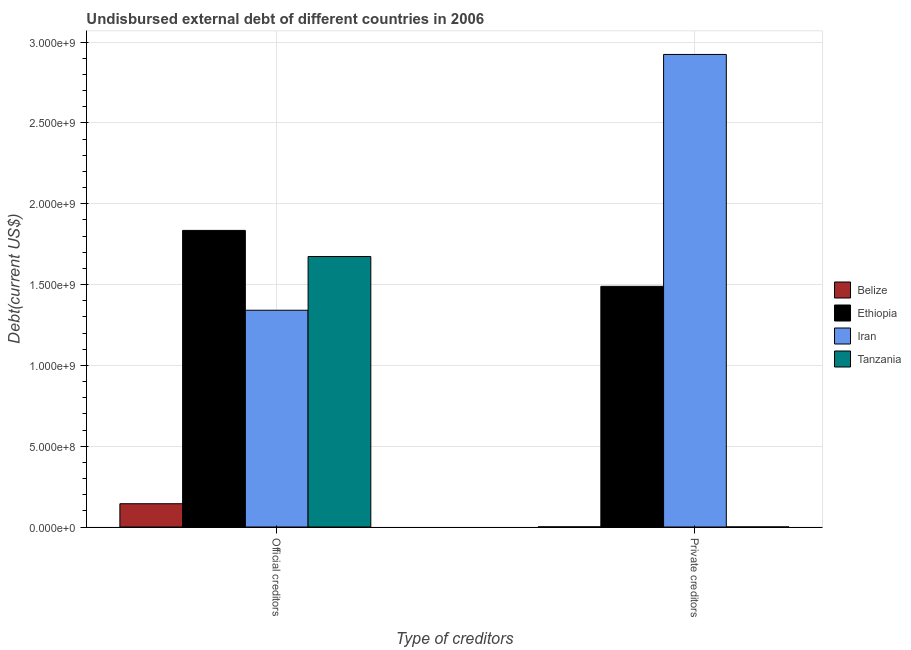How many groups of bars are there?
Your answer should be very brief. 2. Are the number of bars per tick equal to the number of legend labels?
Your response must be concise. Yes. What is the label of the 2nd group of bars from the left?
Your response must be concise. Private creditors. What is the undisbursed external debt of private creditors in Iran?
Your answer should be very brief. 2.92e+09. Across all countries, what is the maximum undisbursed external debt of private creditors?
Your answer should be very brief. 2.92e+09. Across all countries, what is the minimum undisbursed external debt of official creditors?
Your answer should be very brief. 1.44e+08. In which country was the undisbursed external debt of private creditors maximum?
Offer a terse response. Iran. In which country was the undisbursed external debt of private creditors minimum?
Provide a short and direct response. Tanzania. What is the total undisbursed external debt of official creditors in the graph?
Your answer should be compact. 4.99e+09. What is the difference between the undisbursed external debt of official creditors in Ethiopia and that in Belize?
Offer a very short reply. 1.69e+09. What is the difference between the undisbursed external debt of official creditors in Ethiopia and the undisbursed external debt of private creditors in Tanzania?
Give a very brief answer. 1.83e+09. What is the average undisbursed external debt of official creditors per country?
Make the answer very short. 1.25e+09. What is the difference between the undisbursed external debt of private creditors and undisbursed external debt of official creditors in Ethiopia?
Your response must be concise. -3.46e+08. What is the ratio of the undisbursed external debt of private creditors in Tanzania to that in Belize?
Give a very brief answer. 0.46. Is the undisbursed external debt of private creditors in Tanzania less than that in Iran?
Keep it short and to the point. Yes. What does the 1st bar from the left in Official creditors represents?
Your answer should be very brief. Belize. What does the 1st bar from the right in Private creditors represents?
Your answer should be compact. Tanzania. How many bars are there?
Give a very brief answer. 8. How many countries are there in the graph?
Give a very brief answer. 4. Are the values on the major ticks of Y-axis written in scientific E-notation?
Provide a short and direct response. Yes. Does the graph contain any zero values?
Offer a terse response. No. What is the title of the graph?
Your answer should be very brief. Undisbursed external debt of different countries in 2006. Does "Gabon" appear as one of the legend labels in the graph?
Your answer should be very brief. No. What is the label or title of the X-axis?
Ensure brevity in your answer.  Type of creditors. What is the label or title of the Y-axis?
Offer a very short reply. Debt(current US$). What is the Debt(current US$) in Belize in Official creditors?
Keep it short and to the point. 1.44e+08. What is the Debt(current US$) in Ethiopia in Official creditors?
Ensure brevity in your answer.  1.83e+09. What is the Debt(current US$) of Iran in Official creditors?
Your answer should be compact. 1.34e+09. What is the Debt(current US$) in Tanzania in Official creditors?
Your response must be concise. 1.67e+09. What is the Debt(current US$) in Belize in Private creditors?
Provide a succinct answer. 8.87e+05. What is the Debt(current US$) of Ethiopia in Private creditors?
Offer a terse response. 1.49e+09. What is the Debt(current US$) of Iran in Private creditors?
Provide a succinct answer. 2.92e+09. What is the Debt(current US$) in Tanzania in Private creditors?
Provide a short and direct response. 4.06e+05. Across all Type of creditors, what is the maximum Debt(current US$) in Belize?
Offer a terse response. 1.44e+08. Across all Type of creditors, what is the maximum Debt(current US$) of Ethiopia?
Your answer should be very brief. 1.83e+09. Across all Type of creditors, what is the maximum Debt(current US$) in Iran?
Provide a short and direct response. 2.92e+09. Across all Type of creditors, what is the maximum Debt(current US$) of Tanzania?
Offer a very short reply. 1.67e+09. Across all Type of creditors, what is the minimum Debt(current US$) of Belize?
Your answer should be compact. 8.87e+05. Across all Type of creditors, what is the minimum Debt(current US$) in Ethiopia?
Ensure brevity in your answer.  1.49e+09. Across all Type of creditors, what is the minimum Debt(current US$) in Iran?
Your response must be concise. 1.34e+09. Across all Type of creditors, what is the minimum Debt(current US$) in Tanzania?
Your response must be concise. 4.06e+05. What is the total Debt(current US$) in Belize in the graph?
Ensure brevity in your answer.  1.45e+08. What is the total Debt(current US$) of Ethiopia in the graph?
Your answer should be very brief. 3.32e+09. What is the total Debt(current US$) of Iran in the graph?
Your answer should be very brief. 4.26e+09. What is the total Debt(current US$) in Tanzania in the graph?
Provide a short and direct response. 1.67e+09. What is the difference between the Debt(current US$) of Belize in Official creditors and that in Private creditors?
Your answer should be compact. 1.43e+08. What is the difference between the Debt(current US$) in Ethiopia in Official creditors and that in Private creditors?
Your answer should be very brief. 3.46e+08. What is the difference between the Debt(current US$) in Iran in Official creditors and that in Private creditors?
Give a very brief answer. -1.58e+09. What is the difference between the Debt(current US$) of Tanzania in Official creditors and that in Private creditors?
Your answer should be very brief. 1.67e+09. What is the difference between the Debt(current US$) of Belize in Official creditors and the Debt(current US$) of Ethiopia in Private creditors?
Your answer should be very brief. -1.34e+09. What is the difference between the Debt(current US$) of Belize in Official creditors and the Debt(current US$) of Iran in Private creditors?
Your answer should be compact. -2.78e+09. What is the difference between the Debt(current US$) in Belize in Official creditors and the Debt(current US$) in Tanzania in Private creditors?
Provide a short and direct response. 1.44e+08. What is the difference between the Debt(current US$) in Ethiopia in Official creditors and the Debt(current US$) in Iran in Private creditors?
Provide a short and direct response. -1.09e+09. What is the difference between the Debt(current US$) of Ethiopia in Official creditors and the Debt(current US$) of Tanzania in Private creditors?
Your response must be concise. 1.83e+09. What is the difference between the Debt(current US$) of Iran in Official creditors and the Debt(current US$) of Tanzania in Private creditors?
Ensure brevity in your answer.  1.34e+09. What is the average Debt(current US$) in Belize per Type of creditors?
Your answer should be compact. 7.24e+07. What is the average Debt(current US$) of Ethiopia per Type of creditors?
Keep it short and to the point. 1.66e+09. What is the average Debt(current US$) of Iran per Type of creditors?
Offer a very short reply. 2.13e+09. What is the average Debt(current US$) of Tanzania per Type of creditors?
Provide a succinct answer. 8.37e+08. What is the difference between the Debt(current US$) in Belize and Debt(current US$) in Ethiopia in Official creditors?
Ensure brevity in your answer.  -1.69e+09. What is the difference between the Debt(current US$) in Belize and Debt(current US$) in Iran in Official creditors?
Keep it short and to the point. -1.20e+09. What is the difference between the Debt(current US$) in Belize and Debt(current US$) in Tanzania in Official creditors?
Offer a very short reply. -1.53e+09. What is the difference between the Debt(current US$) in Ethiopia and Debt(current US$) in Iran in Official creditors?
Your response must be concise. 4.94e+08. What is the difference between the Debt(current US$) of Ethiopia and Debt(current US$) of Tanzania in Official creditors?
Offer a very short reply. 1.62e+08. What is the difference between the Debt(current US$) of Iran and Debt(current US$) of Tanzania in Official creditors?
Your answer should be compact. -3.32e+08. What is the difference between the Debt(current US$) of Belize and Debt(current US$) of Ethiopia in Private creditors?
Offer a terse response. -1.49e+09. What is the difference between the Debt(current US$) in Belize and Debt(current US$) in Iran in Private creditors?
Make the answer very short. -2.92e+09. What is the difference between the Debt(current US$) of Belize and Debt(current US$) of Tanzania in Private creditors?
Keep it short and to the point. 4.81e+05. What is the difference between the Debt(current US$) of Ethiopia and Debt(current US$) of Iran in Private creditors?
Offer a terse response. -1.43e+09. What is the difference between the Debt(current US$) in Ethiopia and Debt(current US$) in Tanzania in Private creditors?
Provide a succinct answer. 1.49e+09. What is the difference between the Debt(current US$) of Iran and Debt(current US$) of Tanzania in Private creditors?
Offer a terse response. 2.92e+09. What is the ratio of the Debt(current US$) in Belize in Official creditors to that in Private creditors?
Your answer should be compact. 162.34. What is the ratio of the Debt(current US$) in Ethiopia in Official creditors to that in Private creditors?
Your response must be concise. 1.23. What is the ratio of the Debt(current US$) of Iran in Official creditors to that in Private creditors?
Provide a short and direct response. 0.46. What is the ratio of the Debt(current US$) in Tanzania in Official creditors to that in Private creditors?
Provide a succinct answer. 4121.39. What is the difference between the highest and the second highest Debt(current US$) of Belize?
Your response must be concise. 1.43e+08. What is the difference between the highest and the second highest Debt(current US$) of Ethiopia?
Give a very brief answer. 3.46e+08. What is the difference between the highest and the second highest Debt(current US$) in Iran?
Your answer should be very brief. 1.58e+09. What is the difference between the highest and the second highest Debt(current US$) in Tanzania?
Make the answer very short. 1.67e+09. What is the difference between the highest and the lowest Debt(current US$) of Belize?
Your answer should be compact. 1.43e+08. What is the difference between the highest and the lowest Debt(current US$) in Ethiopia?
Give a very brief answer. 3.46e+08. What is the difference between the highest and the lowest Debt(current US$) of Iran?
Your response must be concise. 1.58e+09. What is the difference between the highest and the lowest Debt(current US$) of Tanzania?
Give a very brief answer. 1.67e+09. 